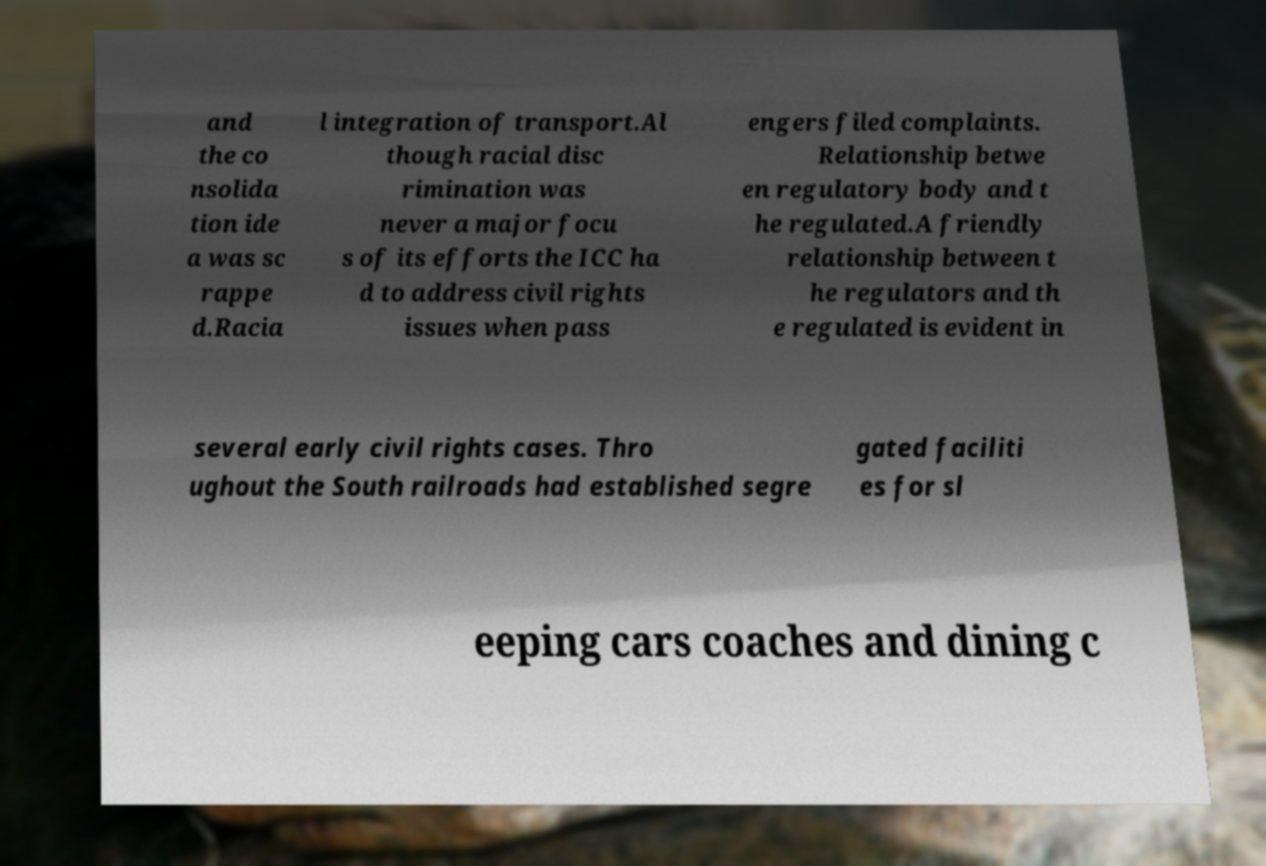Could you extract and type out the text from this image? and the co nsolida tion ide a was sc rappe d.Racia l integration of transport.Al though racial disc rimination was never a major focu s of its efforts the ICC ha d to address civil rights issues when pass engers filed complaints. Relationship betwe en regulatory body and t he regulated.A friendly relationship between t he regulators and th e regulated is evident in several early civil rights cases. Thro ughout the South railroads had established segre gated faciliti es for sl eeping cars coaches and dining c 